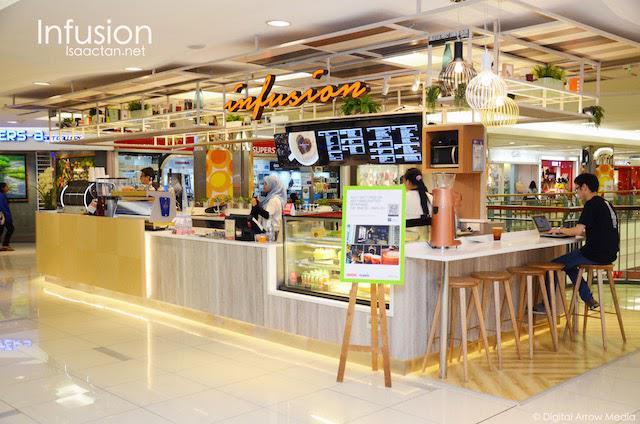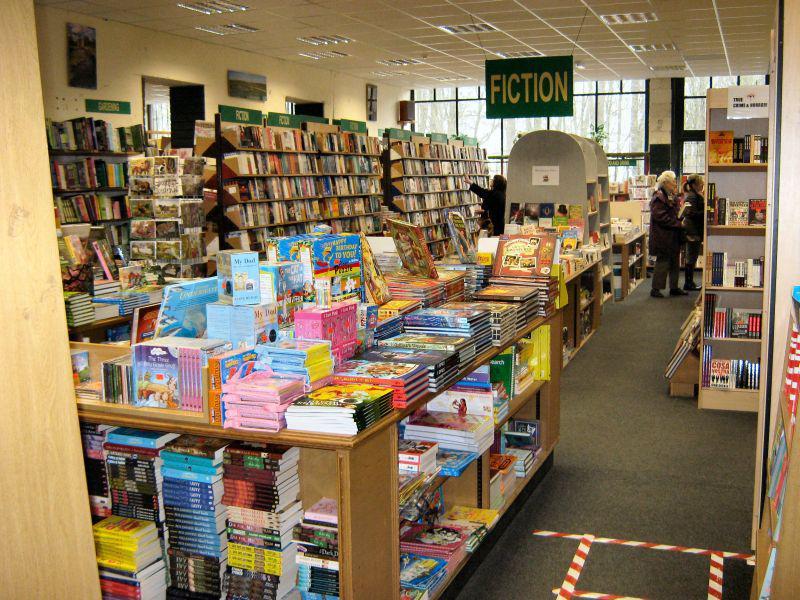The first image is the image on the left, the second image is the image on the right. For the images shown, is this caption "There are no more than 3 people in the image on the left." true? Answer yes or no. No. 